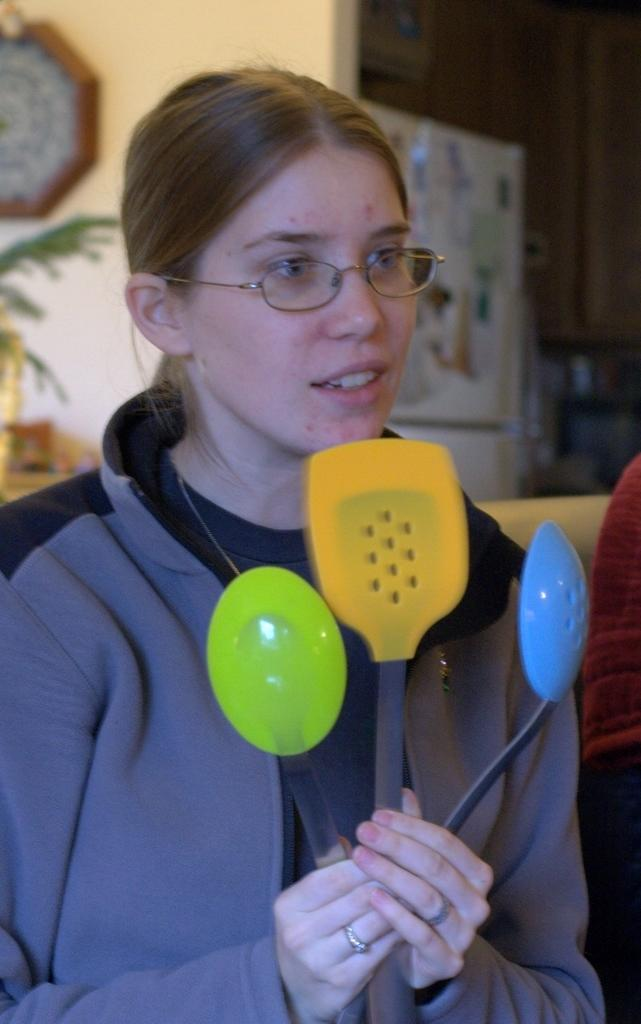Who is present in the image? There is a woman in the image. What is the woman holding in the image? The woman is holding colorful spatulas. What is the woman's facial expression in the image? The woman's mouth is open in the image. What can be seen in the background of the image? There is a wall in the background of the image, and there is a clock on the wall. What type of vegetation is visible in the image? There is a leaf visible in the image. How many cows are visible in the image? There are no cows present in the image. What type of goat can be seen interacting with the woman in the image? There is no goat present in the image; the woman is holding colorful spatulas. 